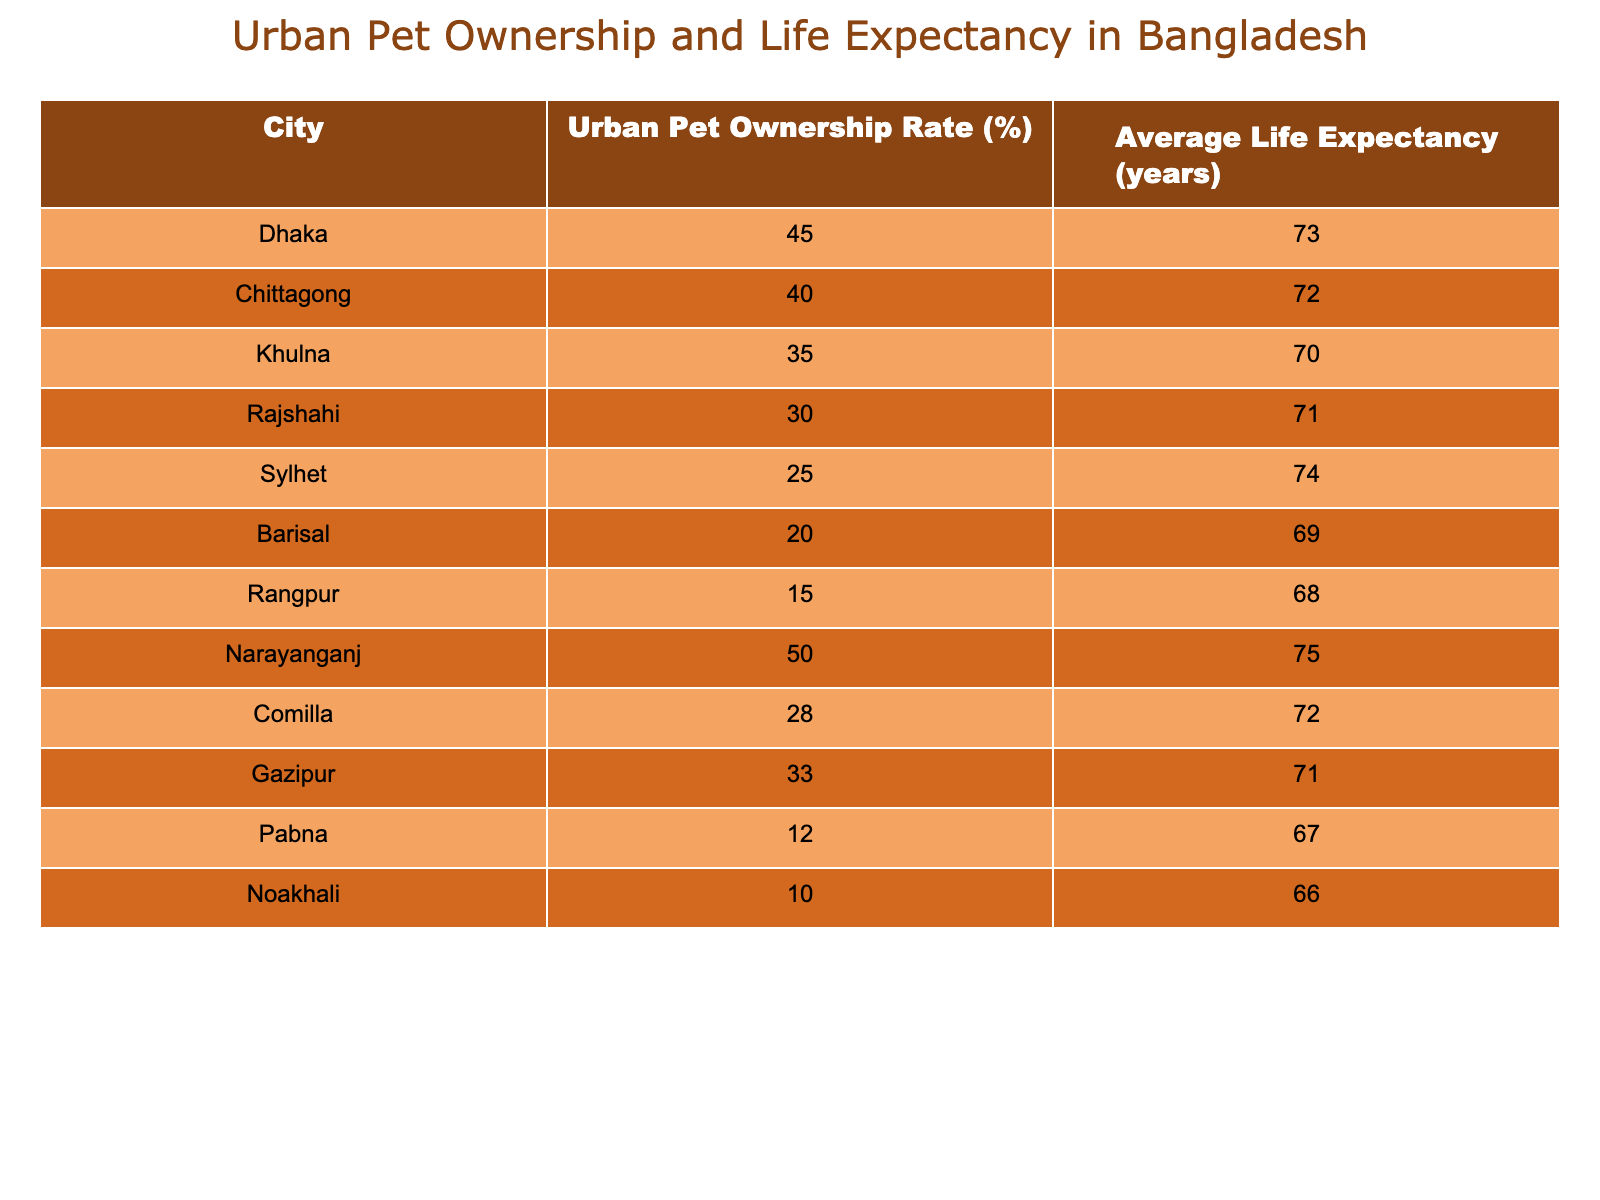What is the average life expectancy in Dhaka? According to the table, the average life expectancy in Dhaka is listed directly, and it shows 73 years.
Answer: 73 years Which city has the highest urban pet ownership rate? By comparing the Urban Pet Ownership Rate column, Narayanganj has the highest rate at 50%.
Answer: Narayanganj What is the difference in life expectancy between the city with the highest and the lowest urban pet ownership rates? The city with the highest rate (Narayanganj) has a life expectancy of 75 years, and the city with the lowest rate (Noakhali) has a life expectancy of 66 years. The difference is 75 - 66 = 9 years.
Answer: 9 years Is the life expectancy in Sylhet greater than in Rajshahi? Comparing the life expectancy values, Sylhet shows 74 years while Rajshahi has 71 years. Therefore, the statement is true.
Answer: Yes Calculate the average urban pet ownership rate across all cities listed. To find the average, sum the urban pet ownership rates: (45 + 40 + 35 + 30 + 25 + 20 + 15 + 50 + 28 + 33 + 12 + 10) =  393. Then divide by the number of cities (12): 393/12 = 32.75%.
Answer: 32.75% Which cities have an average life expectancy of 71 years or more? By looking in the life expectancy column, the cities with 71 years or more are Dhaka (73), Narayanganj (75), Sylhet (74), and Rajshahi (71).
Answer: Dhaka, Narayanganj, Sylhet, Rajshahi Is it true that cities with higher urban pet ownership tend to have higher life expectancy? Analyzing the data, we can see a correlation where cities like Narayanganj and Dhaka with higher ownership have higher life expectancies (75 and 73 respectively). However, exceptions exist, so the statement is generally, but not universally true.
Answer: Generally Yes What is the total urban pet ownership percentage for Chittagong, Khulna, and Barisal? The urban pet ownership rates for these cities are 40% (Chittagong), 35% (Khulna), and 20% (Barisal). Adding them gives: 40 + 35 + 20 = 95%.
Answer: 95% 